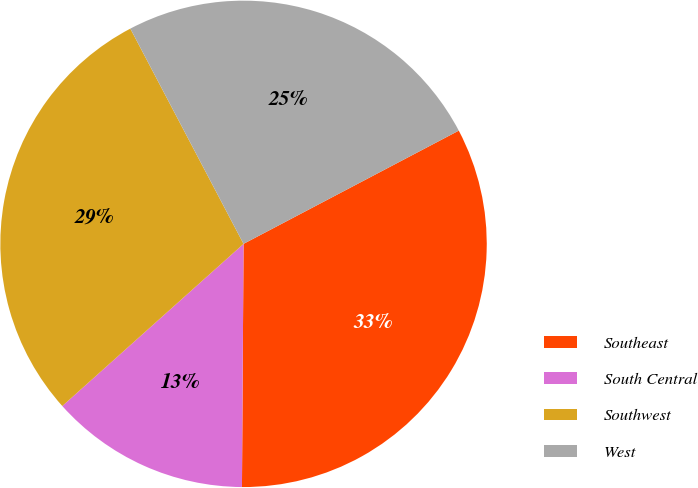Convert chart. <chart><loc_0><loc_0><loc_500><loc_500><pie_chart><fcel>Southeast<fcel>South Central<fcel>Southwest<fcel>West<nl><fcel>32.81%<fcel>13.28%<fcel>28.91%<fcel>25.0%<nl></chart> 